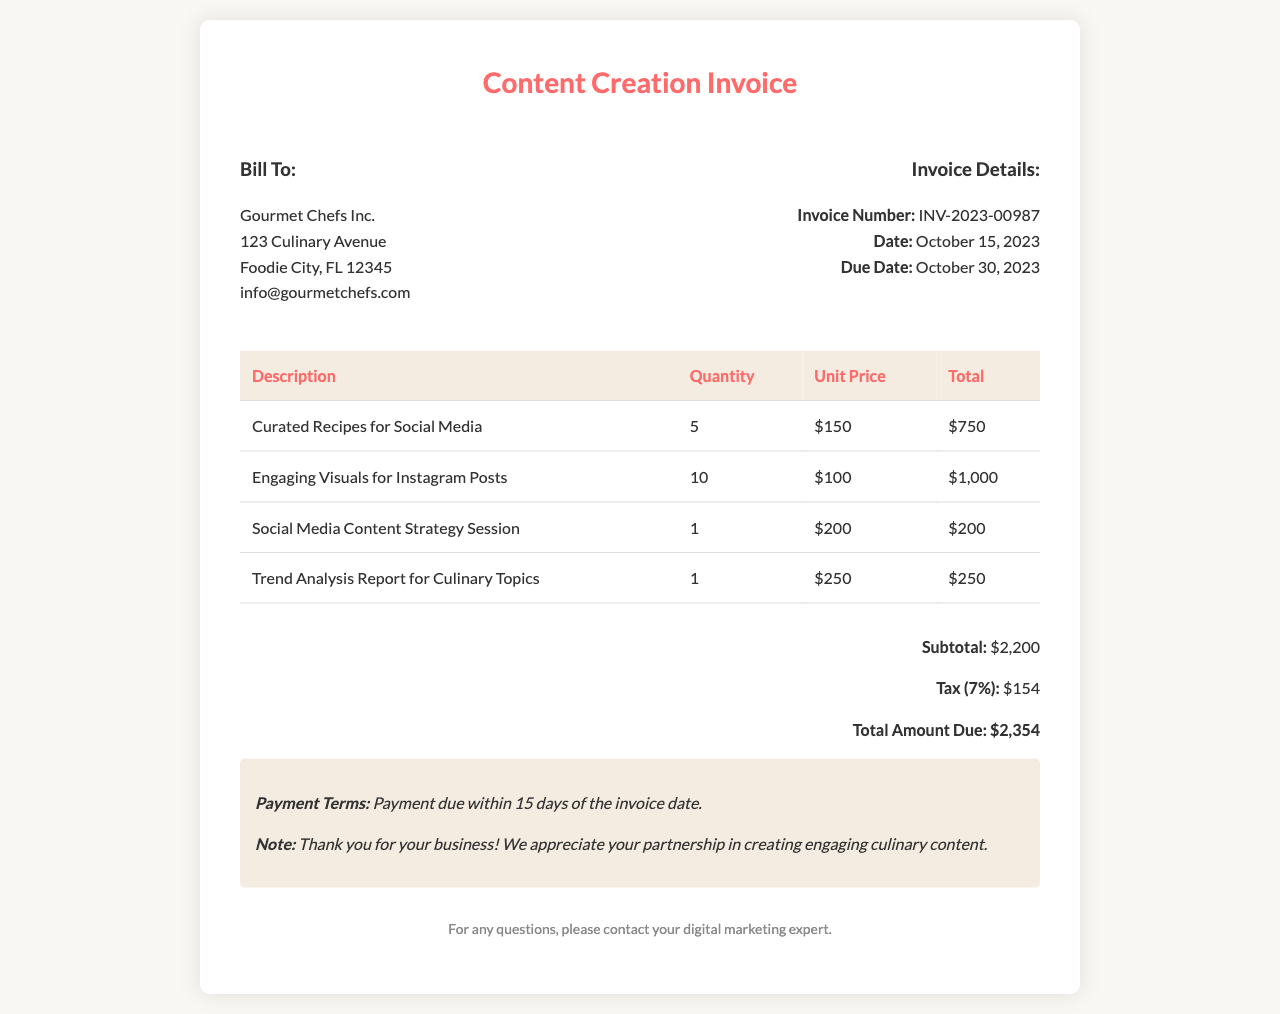What is the invoice number? The invoice number is found in the invoice details section, which is listed as INV-2023-00987.
Answer: INV-2023-00987 What is the total amount due? The total amount due is calculated at the bottom of the invoice, and it is shown as $2,354.
Answer: $2,354 How many curated recipes are included? The number of curated recipes is indicated in the table, where it states 5.
Answer: 5 What date is the invoice due? The due date of the invoice is mentioned under invoice details, which is October 30, 2023.
Answer: October 30, 2023 What is the unit price for engaging visuals for Instagram posts? The unit price for engaging visuals is provided in the invoice table as $100.
Answer: $100 What is the subtotal before tax? The subtotal is listed just before the tax calculation in the invoice as $2,200.
Answer: $2,200 What service has the highest total cost? The service with the highest total is engaging visuals for Instagram posts, which totals $1,000.
Answer: Engaging Visuals for Instagram Posts What are the payment terms stated in the invoice? The payment terms are specified at the end of the invoice indicating payment is due within 15 days of the invoice date.
Answer: Payment due within 15 days What is included in the notes section? The notes section contains information about payment terms and gratitude for the business relationship.
Answer: Payment terms and thank you note 